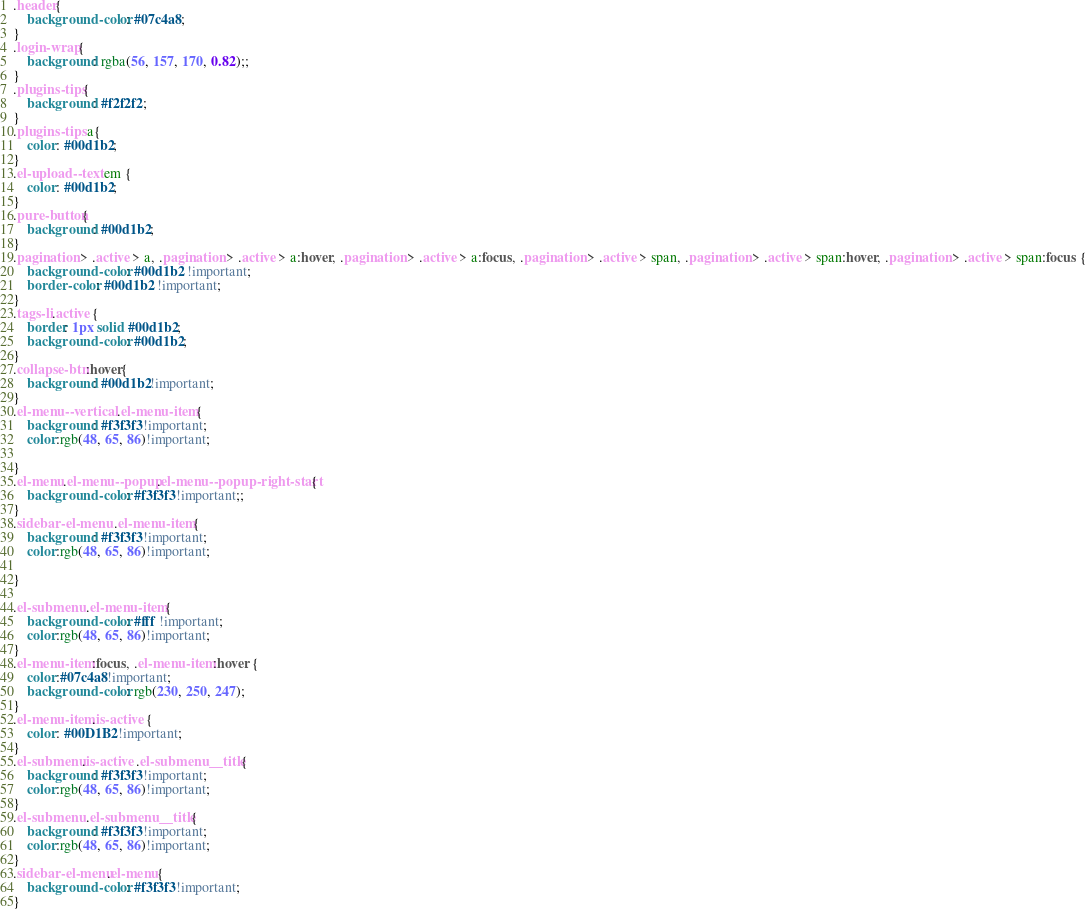Convert code to text. <code><loc_0><loc_0><loc_500><loc_500><_CSS_>.header{
    background-color: #07c4a8;
}
.login-wrap{
    background: rgba(56, 157, 170, 0.82);;
}
.plugins-tips{
    background: #f2f2f2;
}
.plugins-tips a{
    color: #00d1b2;
}
.el-upload--text em {
    color: #00d1b2;
}
.pure-button{
    background: #00d1b2;
}
.pagination > .active > a, .pagination > .active > a:hover, .pagination > .active > a:focus, .pagination > .active > span, .pagination > .active > span:hover, .pagination > .active > span:focus {
    background-color: #00d1b2 !important;
    border-color: #00d1b2 !important;
}
.tags-li.active {
    border: 1px solid #00d1b2;
    background-color: #00d1b2;
}
.collapse-btn:hover{
    background: #00d1b2!important;
}
.el-menu--vertical .el-menu-item{
    background: #f3f3f3!important;
    color:rgb(48, 65, 86)!important;

}
.el-menu.el-menu--popup.el-menu--popup-right-start{
    background-color: #f3f3f3!important;;
}
.sidebar-el-menu  .el-menu-item{
    background: #f3f3f3!important;
    color:rgb(48, 65, 86)!important;

}
  
.el-submenu .el-menu-item{
    background-color: #fff !important;
    color:rgb(48, 65, 86)!important;
}
.el-menu-item:focus, .el-menu-item:hover {
    color:#07c4a8!important;
    background-color: rgb(230, 250, 247);
}
.el-menu-item.is-active {
    color: #00D1B2!important;
}
.el-submenu.is-active .el-submenu__title{
    background: #f3f3f3!important;
    color:rgb(48, 65, 86)!important;
}
.el-submenu .el-submenu__title{
    background: #f3f3f3!important;
    color:rgb(48, 65, 86)!important;
}
.sidebar-el-menu.el-menu{
    background-color: #f3f3f3!important;
}</code> 